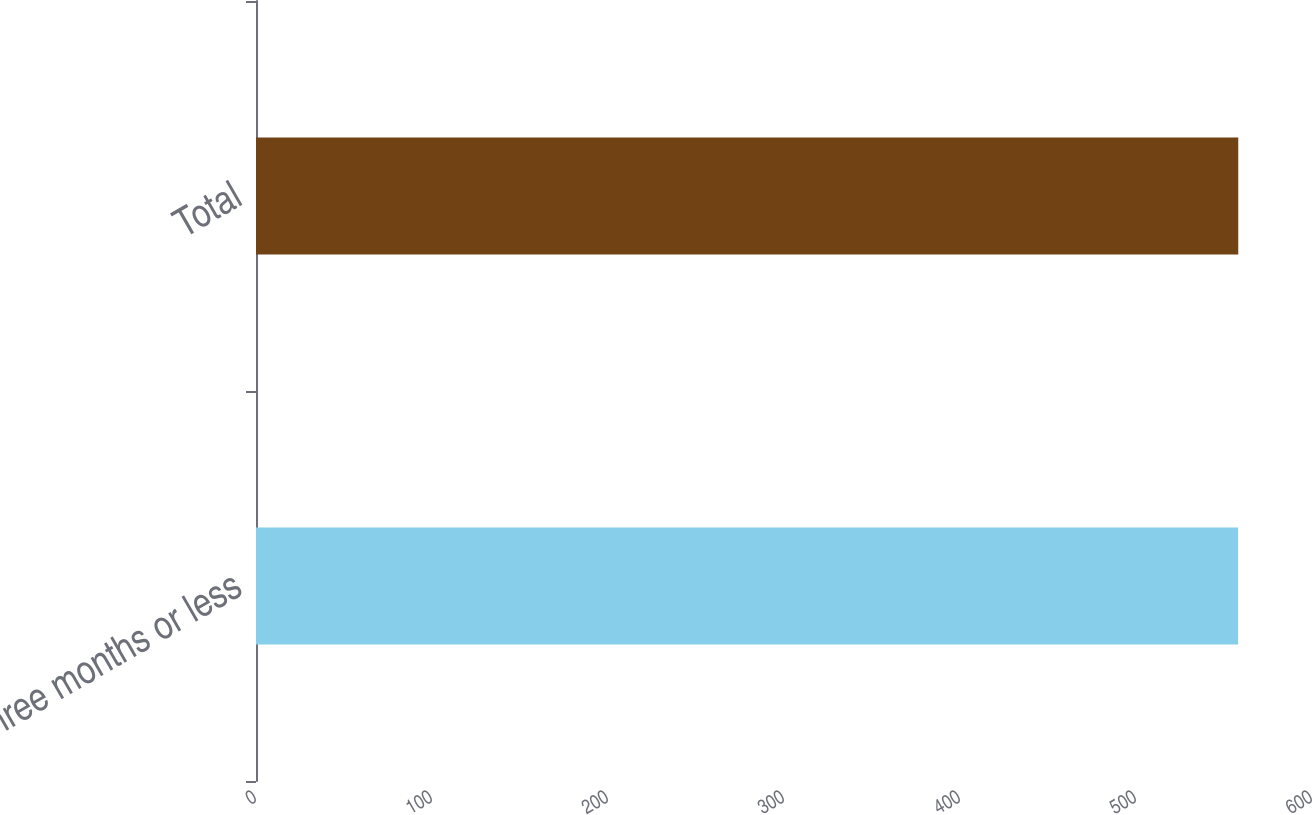Convert chart to OTSL. <chart><loc_0><loc_0><loc_500><loc_500><bar_chart><fcel>Three months or less<fcel>Total<nl><fcel>558<fcel>558.1<nl></chart> 